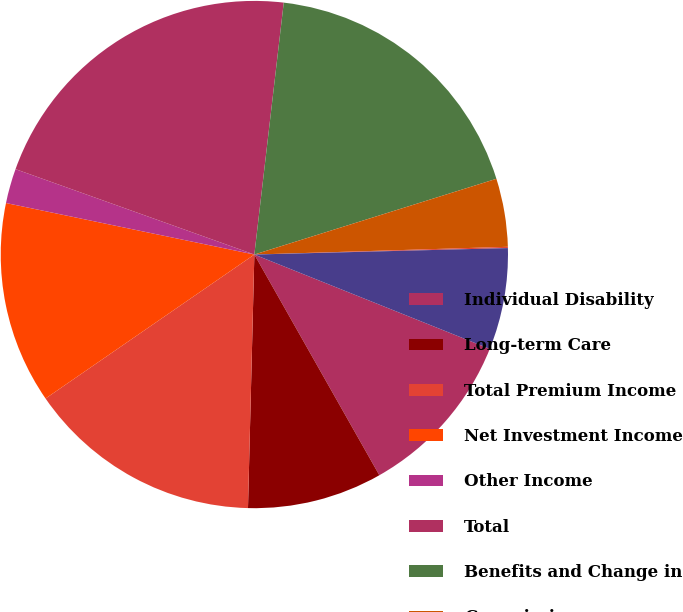Convert chart to OTSL. <chart><loc_0><loc_0><loc_500><loc_500><pie_chart><fcel>Individual Disability<fcel>Long-term Care<fcel>Total Premium Income<fcel>Net Investment Income<fcel>Other Income<fcel>Total<fcel>Benefits and Change in<fcel>Commissions<fcel>Interest and Debt Expense<fcel>Other Expenses<nl><fcel>10.73%<fcel>8.6%<fcel>14.99%<fcel>12.86%<fcel>2.21%<fcel>21.38%<fcel>18.32%<fcel>4.34%<fcel>0.08%<fcel>6.47%<nl></chart> 